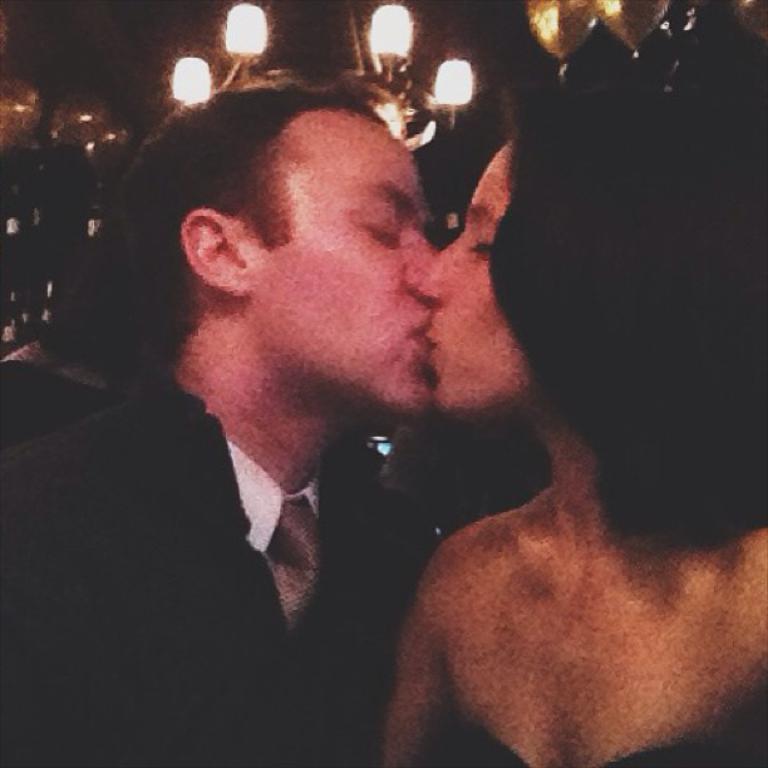Could you give a brief overview of what you see in this image? In this image I can see a man and a woman in the front. I can see both of them are kissing. On the top side of the image I can see few lights and I can also see this image is little bit blurry. 